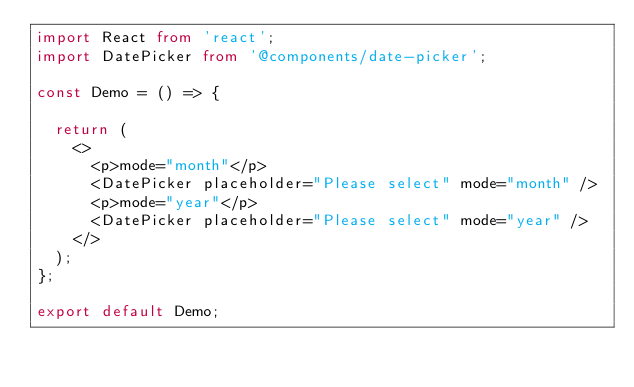<code> <loc_0><loc_0><loc_500><loc_500><_TypeScript_>import React from 'react';
import DatePicker from '@components/date-picker';

const Demo = () => {

  return (
    <>
      <p>mode="month"</p>
      <DatePicker placeholder="Please select" mode="month" />
      <p>mode="year"</p>
      <DatePicker placeholder="Please select" mode="year" />
    </>
  );
};

export default Demo;
</code> 